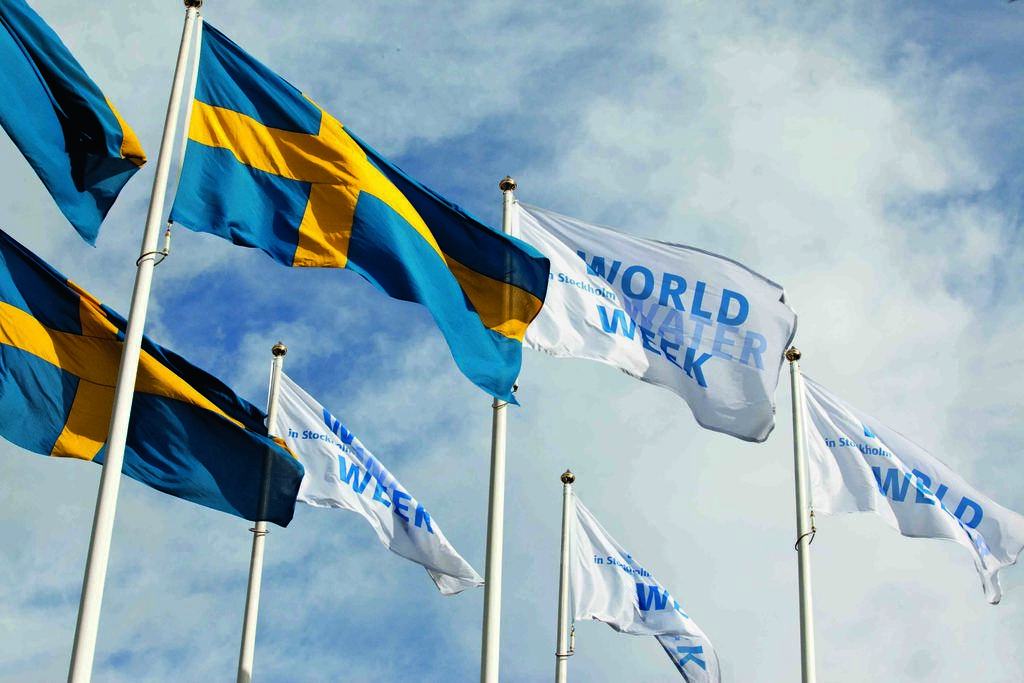What objects are on poles in the image? There are flags on poles in the image. How can the flags be distinguished from one another? The flags are in different colors. What can be seen in the background of the image? There is a sky visible in the background of the image. What is the weather like in the image? Clouds are present in the sky, indicating that it might be partly cloudy. What type of hook is attached to the flagpole in the image? There is no hook present on the flagpoles in the image. What type of apparel is being worn by the clouds in the image? Clouds do not wear apparel, as they are atmospheric phenomena and not living beings. 